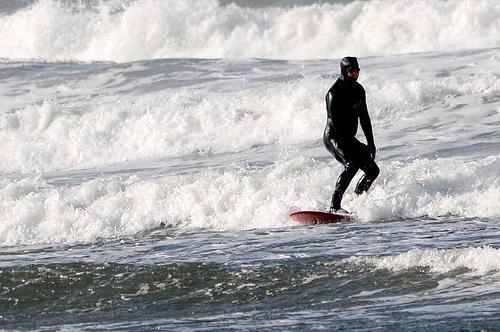How many waves are visible?
Give a very brief answer. 4. 